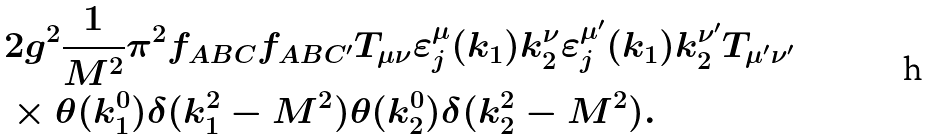Convert formula to latex. <formula><loc_0><loc_0><loc_500><loc_500>& 2 g ^ { 2 } \frac { 1 } { M ^ { 2 } } \pi ^ { 2 } f _ { A B C } f _ { A B C ^ { \prime } } T _ { \mu \nu } \varepsilon ^ { \mu } _ { j } ( k _ { 1 } ) k _ { 2 } ^ { \nu } \varepsilon ^ { \mu ^ { \prime } } _ { j } ( k _ { 1 } ) k _ { 2 } ^ { \nu ^ { \prime } } T _ { \mu ^ { \prime } \nu ^ { \prime } } \\ & \times \theta ( k _ { 1 } ^ { 0 } ) \delta ( k _ { 1 } ^ { 2 } - M ^ { 2 } ) \theta ( k _ { 2 } ^ { 0 } ) \delta ( k _ { 2 } ^ { 2 } - M ^ { 2 } ) .</formula> 